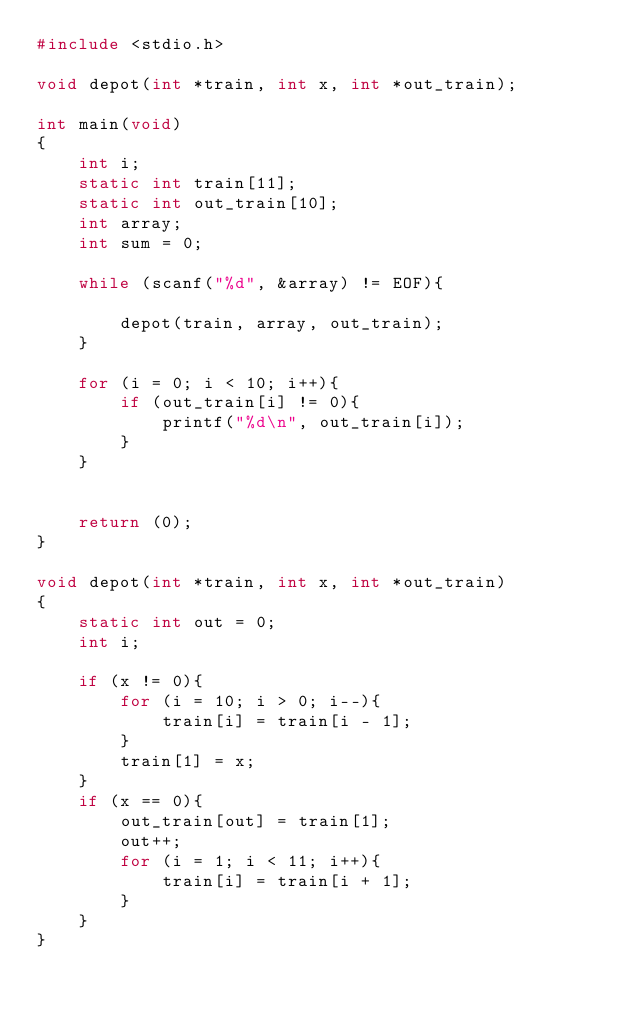<code> <loc_0><loc_0><loc_500><loc_500><_C_>#include <stdio.h>

void depot(int *train, int x, int *out_train);

int main(void)
{
	int i;
	static int train[11];
	static int out_train[10];
	int array;
	int sum = 0;
	
	while (scanf("%d", &array) != EOF){
		
		depot(train, array, out_train);
	}
	
	for (i = 0; i < 10; i++){
		if (out_train[i] != 0){
			printf("%d\n", out_train[i]);
		}
	}
	
	
	return (0);
}

void depot(int *train, int x, int *out_train)
{
	static int out = 0;
	int i;
	
	if (x != 0){
		for (i = 10; i > 0; i--){
			train[i] = train[i - 1];
		}
		train[1] = x;
	}
	if (x == 0){
		out_train[out] = train[1];
		out++;
		for (i = 1; i < 11; i++){
			train[i] = train[i + 1];
		}
	}
}</code> 